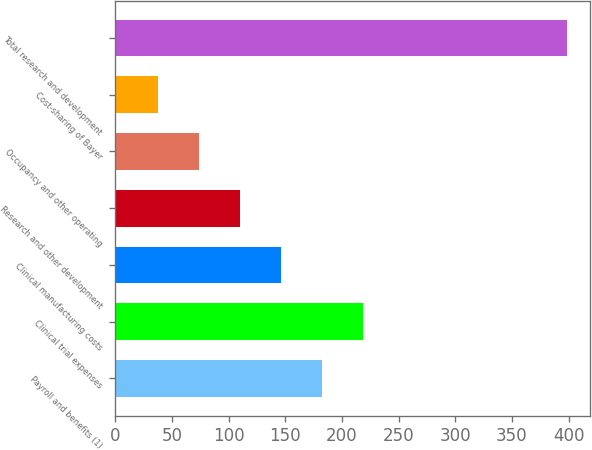<chart> <loc_0><loc_0><loc_500><loc_500><bar_chart><fcel>Payroll and benefits (1)<fcel>Clinical trial expenses<fcel>Clinical manufacturing costs<fcel>Research and other development<fcel>Occupancy and other operating<fcel>Cost-sharing of Bayer<fcel>Total research and development<nl><fcel>182.14<fcel>218.25<fcel>146.03<fcel>109.92<fcel>73.81<fcel>37.7<fcel>398.8<nl></chart> 